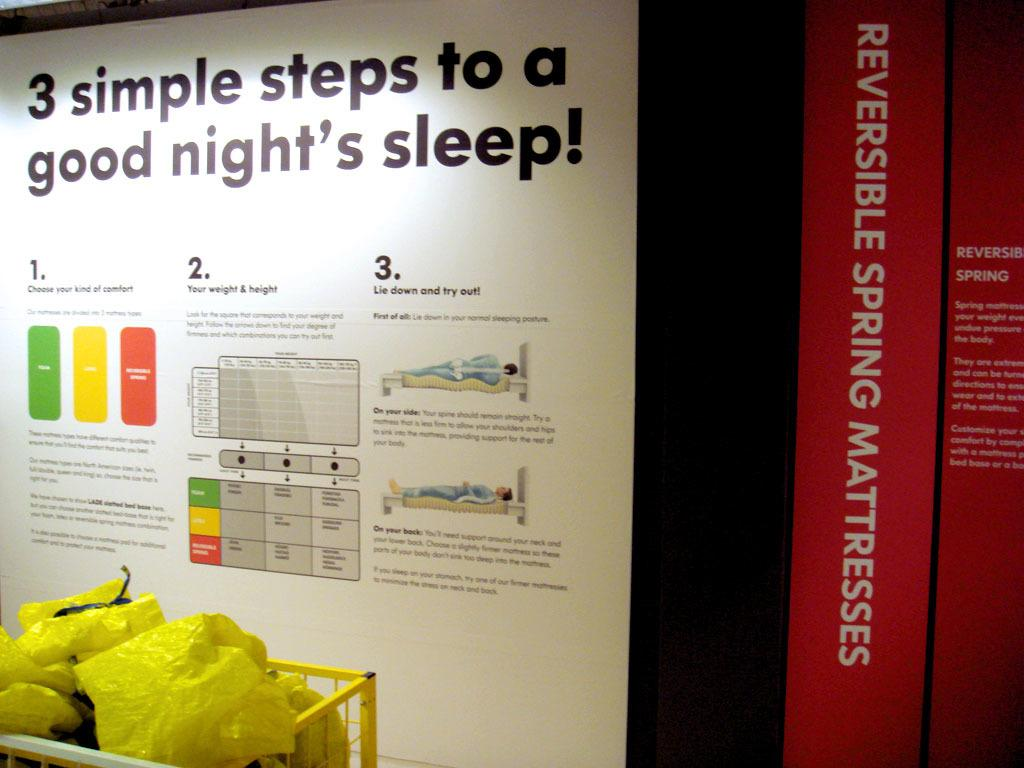<image>
Describe the image concisely. Yellow bags of trash are in front of a flyer instructing 3 steps for good sleep. 